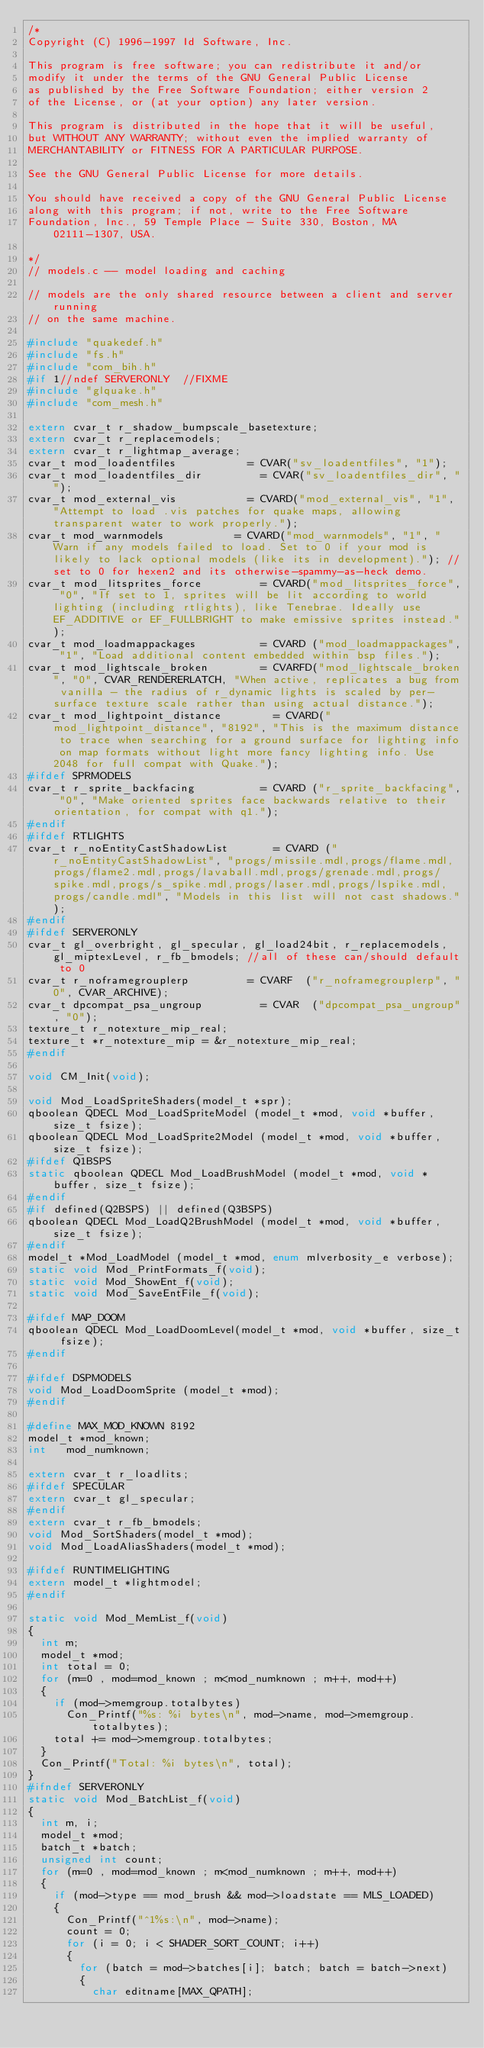<code> <loc_0><loc_0><loc_500><loc_500><_C_>/*
Copyright (C) 1996-1997 Id Software, Inc.

This program is free software; you can redistribute it and/or
modify it under the terms of the GNU General Public License
as published by the Free Software Foundation; either version 2
of the License, or (at your option) any later version.

This program is distributed in the hope that it will be useful,
but WITHOUT ANY WARRANTY; without even the implied warranty of
MERCHANTABILITY or FITNESS FOR A PARTICULAR PURPOSE.  

See the GNU General Public License for more details.

You should have received a copy of the GNU General Public License
along with this program; if not, write to the Free Software
Foundation, Inc., 59 Temple Place - Suite 330, Boston, MA  02111-1307, USA.

*/
// models.c -- model loading and caching

// models are the only shared resource between a client and server running
// on the same machine.

#include "quakedef.h"
#include "fs.h"
#include "com_bih.h"
#if 1//ndef SERVERONLY	//FIXME
#include "glquake.h"
#include "com_mesh.h"

extern cvar_t r_shadow_bumpscale_basetexture;
extern cvar_t r_replacemodels;
extern cvar_t r_lightmap_average;
cvar_t mod_loadentfiles						= CVAR("sv_loadentfiles", "1");
cvar_t mod_loadentfiles_dir					= CVAR("sv_loadentfiles_dir", "");
cvar_t mod_external_vis						= CVARD("mod_external_vis", "1", "Attempt to load .vis patches for quake maps, allowing transparent water to work properly.");
cvar_t mod_warnmodels						= CVARD("mod_warnmodels", "1", "Warn if any models failed to load. Set to 0 if your mod is likely to lack optional models (like its in development).");	//set to 0 for hexen2 and its otherwise-spammy-as-heck demo.
cvar_t mod_litsprites_force					= CVARD("mod_litsprites_force", "0", "If set to 1, sprites will be lit according to world lighting (including rtlights), like Tenebrae. Ideally use EF_ADDITIVE or EF_FULLBRIGHT to make emissive sprites instead.");
cvar_t mod_loadmappackages					= CVARD ("mod_loadmappackages", "1", "Load additional content embedded within bsp files.");
cvar_t mod_lightscale_broken				= CVARFD("mod_lightscale_broken", "0", CVAR_RENDERERLATCH, "When active, replicates a bug from vanilla - the radius of r_dynamic lights is scaled by per-surface texture scale rather than using actual distance.");
cvar_t mod_lightpoint_distance				= CVARD("mod_lightpoint_distance", "8192", "This is the maximum distance to trace when searching for a ground surface for lighting info on map formats without light more fancy lighting info. Use 2048 for full compat with Quake.");
#ifdef SPRMODELS
cvar_t r_sprite_backfacing					= CVARD	("r_sprite_backfacing", "0", "Make oriented sprites face backwards relative to their orientation, for compat with q1.");
#endif
#ifdef RTLIGHTS
cvar_t r_noEntityCastShadowList				= CVARD ("r_noEntityCastShadowList", "progs/missile.mdl,progs/flame.mdl,progs/flame2.mdl,progs/lavaball.mdl,progs/grenade.mdl,progs/spike.mdl,progs/s_spike.mdl,progs/laser.mdl,progs/lspike.mdl,progs/candle.mdl", "Models in this list will not cast shadows.");
#endif
#ifdef SERVERONLY
cvar_t gl_overbright, gl_specular, gl_load24bit, r_replacemodels, gl_miptexLevel, r_fb_bmodels;	//all of these can/should default to 0
cvar_t r_noframegrouplerp					= CVARF  ("r_noframegrouplerp", "0", CVAR_ARCHIVE);
cvar_t dpcompat_psa_ungroup					= CVAR  ("dpcompat_psa_ungroup", "0");
texture_t	r_notexture_mip_real;
texture_t	*r_notexture_mip = &r_notexture_mip_real;
#endif

void CM_Init(void);

void Mod_LoadSpriteShaders(model_t *spr);
qboolean QDECL Mod_LoadSpriteModel (model_t *mod, void *buffer, size_t fsize);
qboolean QDECL Mod_LoadSprite2Model (model_t *mod, void *buffer, size_t fsize);
#ifdef Q1BSPS
static qboolean QDECL Mod_LoadBrushModel (model_t *mod, void *buffer, size_t fsize);
#endif
#if defined(Q2BSPS) || defined(Q3BSPS)
qboolean QDECL Mod_LoadQ2BrushModel (model_t *mod, void *buffer, size_t fsize);
#endif
model_t *Mod_LoadModel (model_t *mod, enum mlverbosity_e verbose);
static void Mod_PrintFormats_f(void);
static void Mod_ShowEnt_f(void);
static void Mod_SaveEntFile_f(void);

#ifdef MAP_DOOM
qboolean QDECL Mod_LoadDoomLevel(model_t *mod, void *buffer, size_t fsize);
#endif

#ifdef DSPMODELS
void Mod_LoadDoomSprite (model_t *mod);
#endif

#define	MAX_MOD_KNOWN	8192
model_t	*mod_known;
int		mod_numknown;

extern cvar_t r_loadlits;
#ifdef SPECULAR
extern cvar_t gl_specular;
#endif
extern cvar_t r_fb_bmodels;
void Mod_SortShaders(model_t *mod);
void Mod_LoadAliasShaders(model_t *mod);

#ifdef RUNTIMELIGHTING
extern model_t *lightmodel;
#endif

static void Mod_MemList_f(void)
{
	int m;
	model_t *mod;
	int total = 0;
	for (m=0 , mod=mod_known ; m<mod_numknown ; m++, mod++)
	{
		if (mod->memgroup.totalbytes)
			Con_Printf("%s: %i bytes\n", mod->name, mod->memgroup.totalbytes);
		total += mod->memgroup.totalbytes;
	}
	Con_Printf("Total: %i bytes\n", total);
}
#ifndef SERVERONLY
static void Mod_BatchList_f(void)
{
	int m, i;
	model_t *mod;
	batch_t *batch;
	unsigned int count;
	for (m=0 , mod=mod_known ; m<mod_numknown ; m++, mod++)
	{
		if (mod->type == mod_brush && mod->loadstate == MLS_LOADED)
		{
			Con_Printf("^1%s:\n", mod->name);
			count = 0;
			for (i = 0; i < SHADER_SORT_COUNT; i++)
			{
				for (batch = mod->batches[i]; batch; batch = batch->next)
				{
					char editname[MAX_QPATH];</code> 